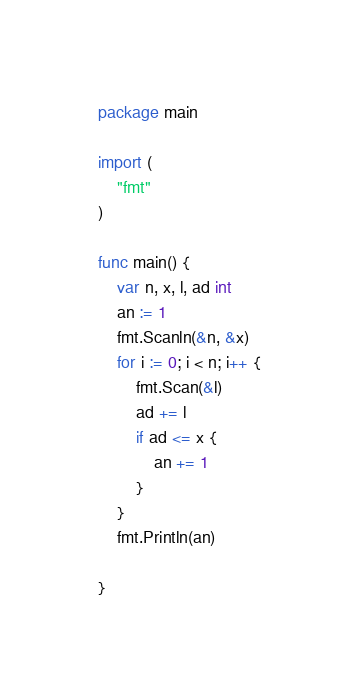<code> <loc_0><loc_0><loc_500><loc_500><_Go_>package main

import (
	"fmt"
)

func main() {
	var n, x, l, ad int
	an := 1
	fmt.Scanln(&n, &x)
	for i := 0; i < n; i++ {
		fmt.Scan(&l)
		ad += l
		if ad <= x {
			an += 1
		}
	}
	fmt.Println(an)

}</code> 